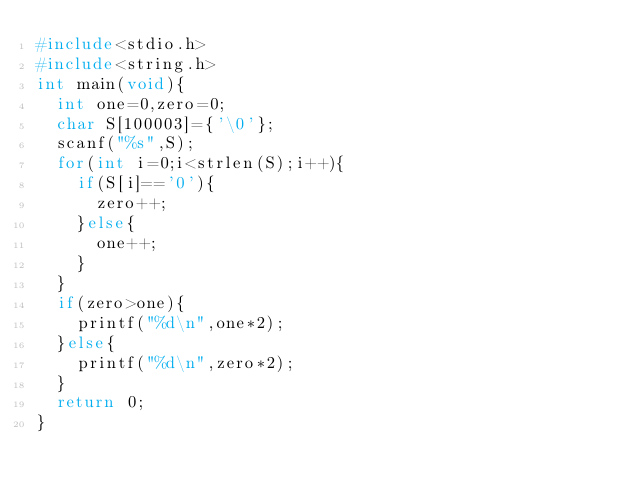Convert code to text. <code><loc_0><loc_0><loc_500><loc_500><_C_>#include<stdio.h>
#include<string.h>
int main(void){
  int one=0,zero=0;
  char S[100003]={'\0'};
  scanf("%s",S);
  for(int i=0;i<strlen(S);i++){
    if(S[i]=='0'){
      zero++;
    }else{
      one++;
    }
  }
  if(zero>one){
    printf("%d\n",one*2);
  }else{
    printf("%d\n",zero*2);
  }
  return 0;
}</code> 